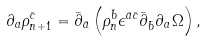<formula> <loc_0><loc_0><loc_500><loc_500>\partial _ { a } \rho ^ { \bar { c } } _ { n + 1 } = \bar { \partial } _ { \bar { a } } \left ( \rho _ { n } ^ { \bar { b } } \epsilon ^ { \bar { a } \bar { c } } \bar { \partial } _ { \bar { b } } \partial _ { a } \Omega \right ) ,</formula> 